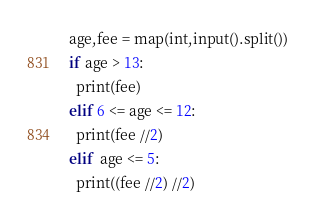Convert code to text. <code><loc_0><loc_0><loc_500><loc_500><_Python_>age,fee = map(int,input().split())
if age > 13:
  print(fee)
elif 6 <= age <= 12:
  print(fee //2)
elif  age <= 5:
  print((fee //2) //2)</code> 